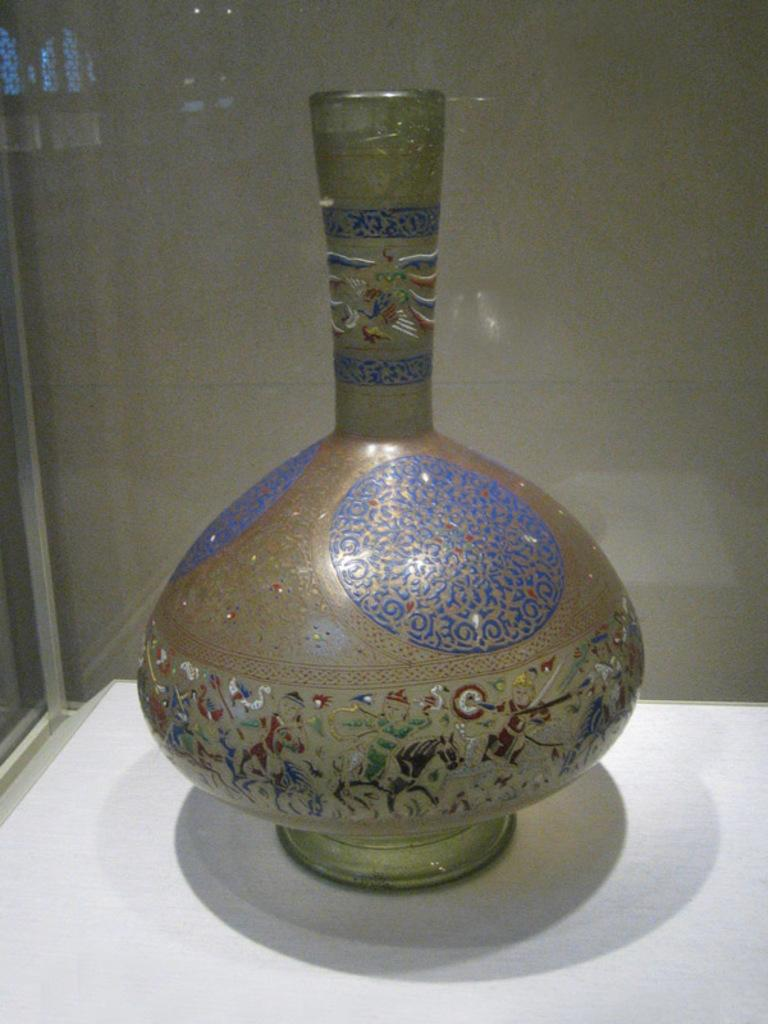What is the main subject in the center of the image? There is a port in the center of the image. What is the color of the surface on which the port is placed? The port is placed on a white surface. What type of disease is being treated at the port in the image? There is no indication of a disease or any medical treatment in the image; it simply features a port on a white surface. 